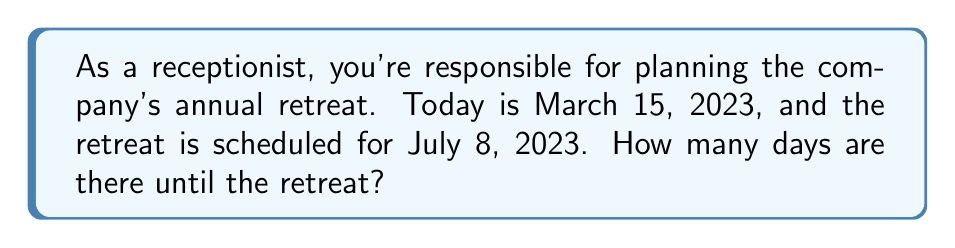Provide a solution to this math problem. To solve this problem, we need to calculate the number of days between March 15, 2023, and July 8, 2023. Let's break it down step by step:

1. Count the remaining days in March:
   March has 31 days, so there are 31 - 15 = 16 days left in March.

2. Count the full months between March and July:
   April (30 days), May (31 days), and June (30 days).

3. Count the days in July until the retreat:
   The retreat is on July 8, so we count 8 days.

4. Sum up all the days:
   $$ \text{Total days} = 16 + 30 + 31 + 30 + 8 $$

5. Calculate the sum:
   $$ \text{Total days} = 115 $$

Therefore, there are 115 days until the company retreat.
Answer: 115 days 